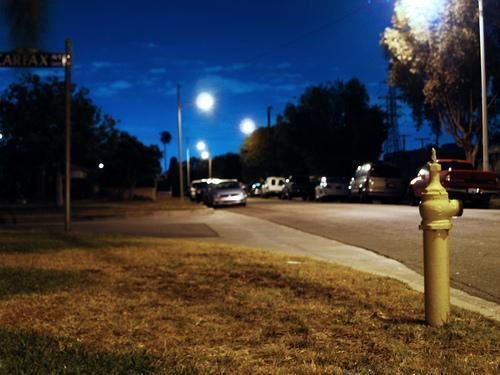How many fire hydrants are in the photo?
Give a very brief answer. 1. How many trucks are in the photo?
Give a very brief answer. 2. 